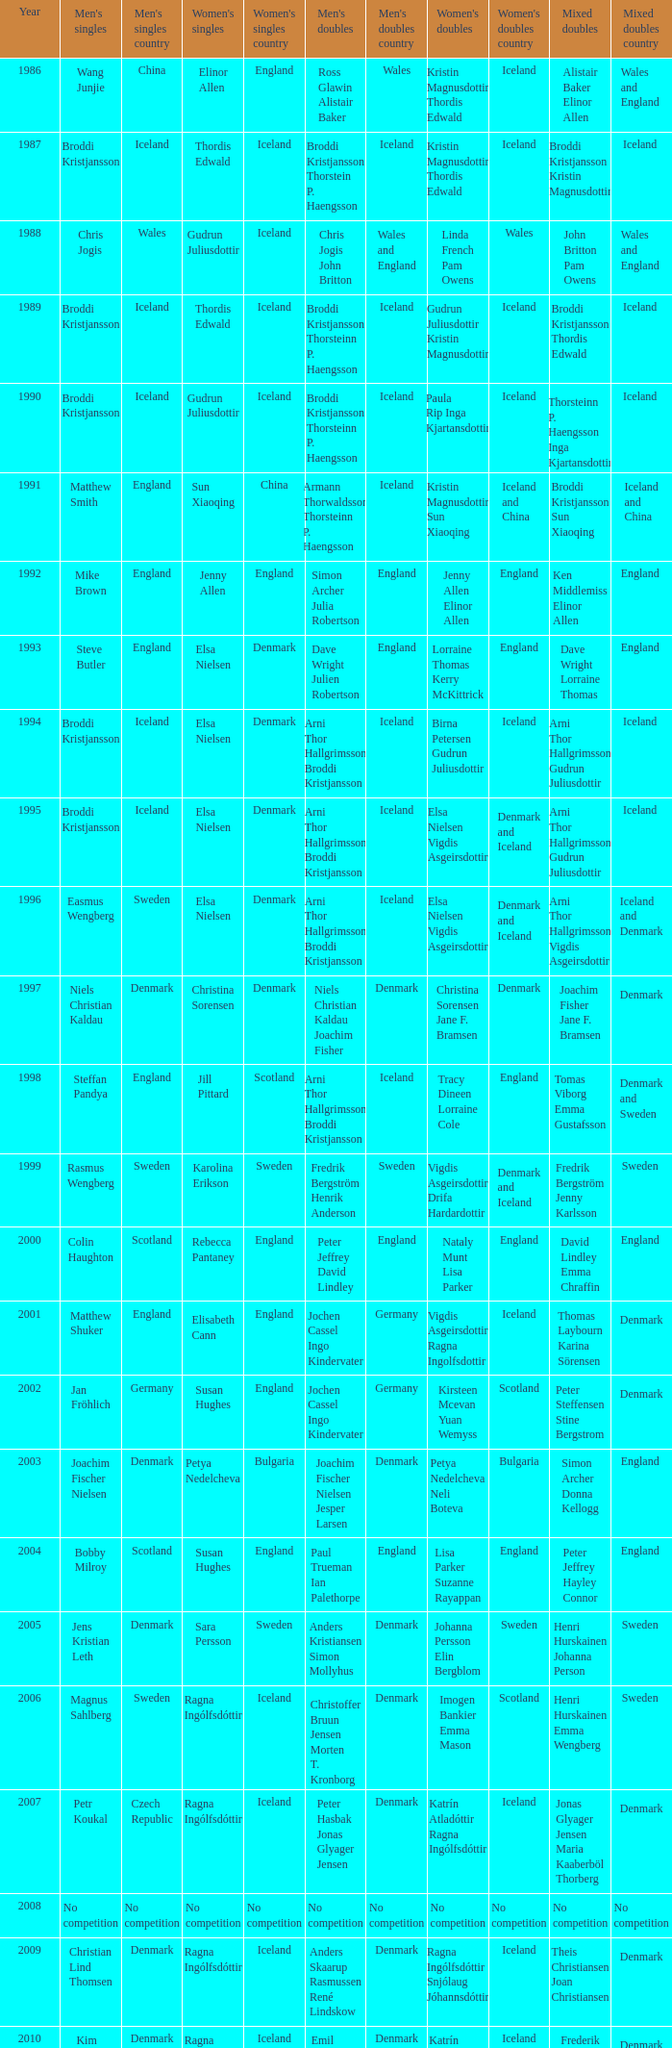In which women's doubles did Wang Junjie play men's singles? Kristin Magnusdottir Thordis Edwald. 